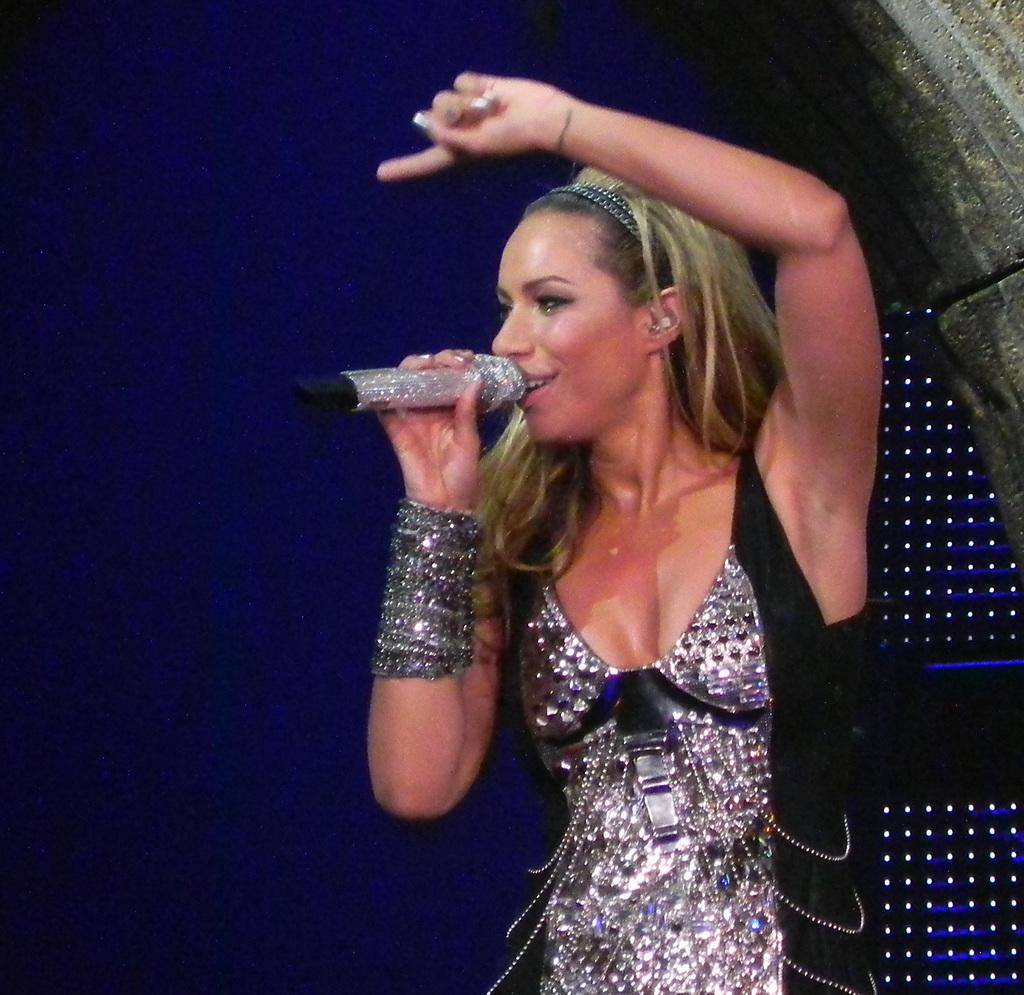Who is the main subject in the image? There is a woman in the image. What is the woman doing in the image? The woman is singing. What object is in front of the woman? There is a microphone in front of the woman. What is the color of the background in the image? The background color is blue. What type of shoes is the monkey wearing in the image? There is no monkey present in the image, and therefore no shoes to describe. 